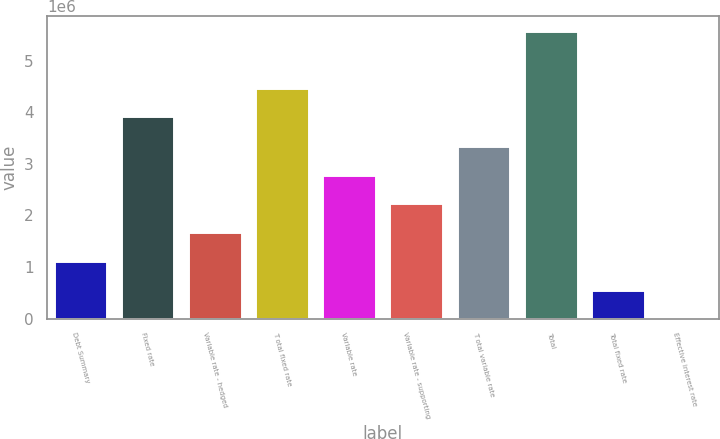<chart> <loc_0><loc_0><loc_500><loc_500><bar_chart><fcel>Debt Summary<fcel>Fixed rate<fcel>Variable rate - hedged<fcel>T otal fixed rate<fcel>Variable rate<fcel>Variable rate - supporting<fcel>T otal variable rate<fcel>Total<fcel>Total fixed rate<fcel>Effective interest rate<nl><fcel>1.11632e+06<fcel>3.91845e+06<fcel>1.67447e+06<fcel>4.47661e+06<fcel>2.79078e+06<fcel>2.23263e+06<fcel>3.34894e+06<fcel>5.58156e+06<fcel>558161<fcel>5.24<nl></chart> 